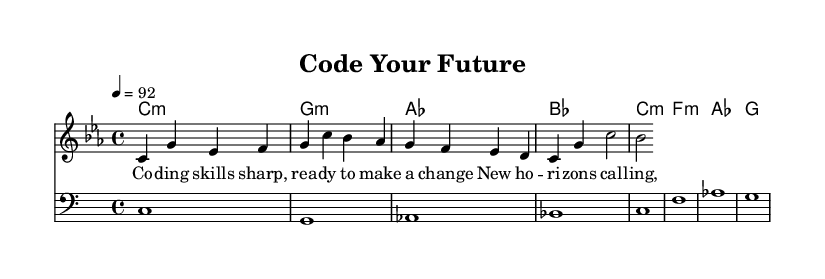What is the key signature of this music? The key signature is C minor, which has three flats (B, E, and A). This can be identified at the beginning of the score, where the key signature is indicated.
Answer: C minor What is the time signature of this piece? The time signature is 4/4, meaning there are four beats per measure, and a quarter note gets one beat. This information can be found at the beginning of the score next to the key signature.
Answer: 4/4 What is the tempo marking for this music? The tempo marking indicates a speed of 92 beats per minute, denoted as "4 = 92." This is shown at the beginning of the score, indicating how fast the piece should be played.
Answer: 92 How many measures are in the melody? The melody consists of four measures, as there are four groups of notes separated by vertical lines (bar lines) indicating the end of each measure.
Answer: 4 Which chord is played in the first measure? The chord played in the first measure is C minor, indicated by the first chord name listed in the chord section. This is determined by looking at the harmonies notated alongside the melody.
Answer: C:m What are the lyrics for the first line of the verse? The first line of the verse is "Co -- ding skills sharp, rea -- dy to make a change," which can be found directly under the melody notes. Each syllable is aligned with the corresponding note, making it clear to see the lyrics.
Answer: Co -- ding skills sharp, rea -- dy to make a change How many different chord types are used in the harmonies? There are four different chord types: minor, major. This is determined by examining the chord names in the harmonies section of the score and counting the variations.
Answer: 2 